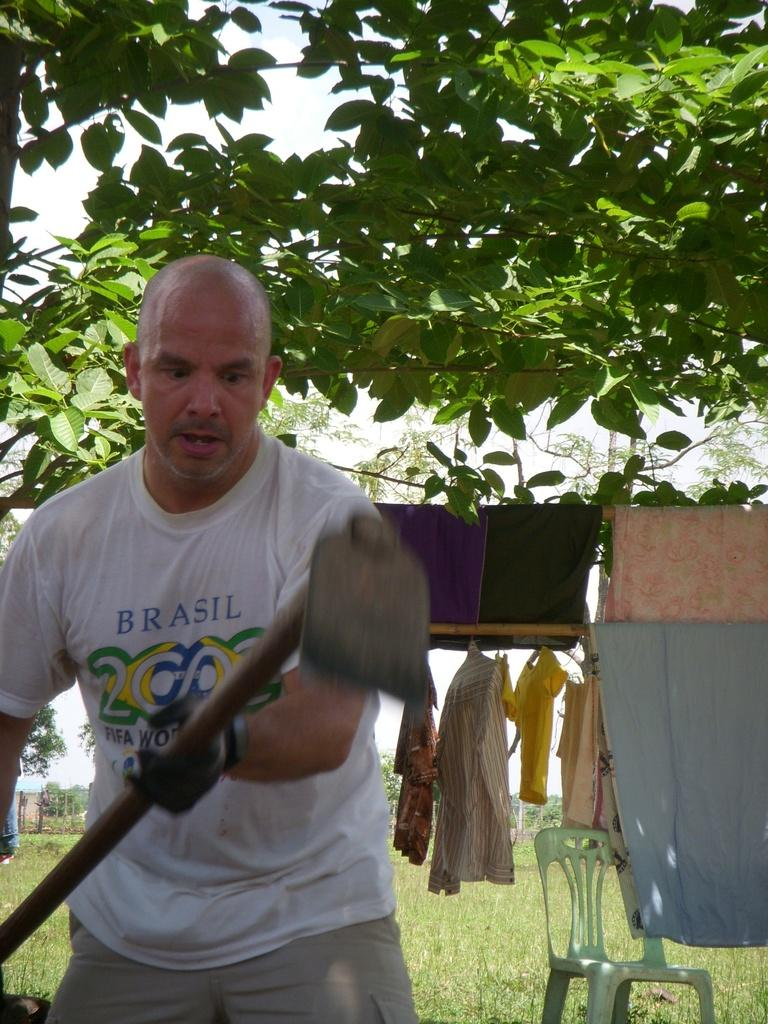Who is in the image? There is a man in the image. What is the man doing in the image? The man is standing in the image. What object is the man holding in his hand? The man is holding an axe in his hand. What can be seen in the background of the image? There are trees and clothes hangers in the background of the image. What is the price of the queen's gown in the image? There is no queen or gown present in the image, so it is not possible to determine the price of a gown. 